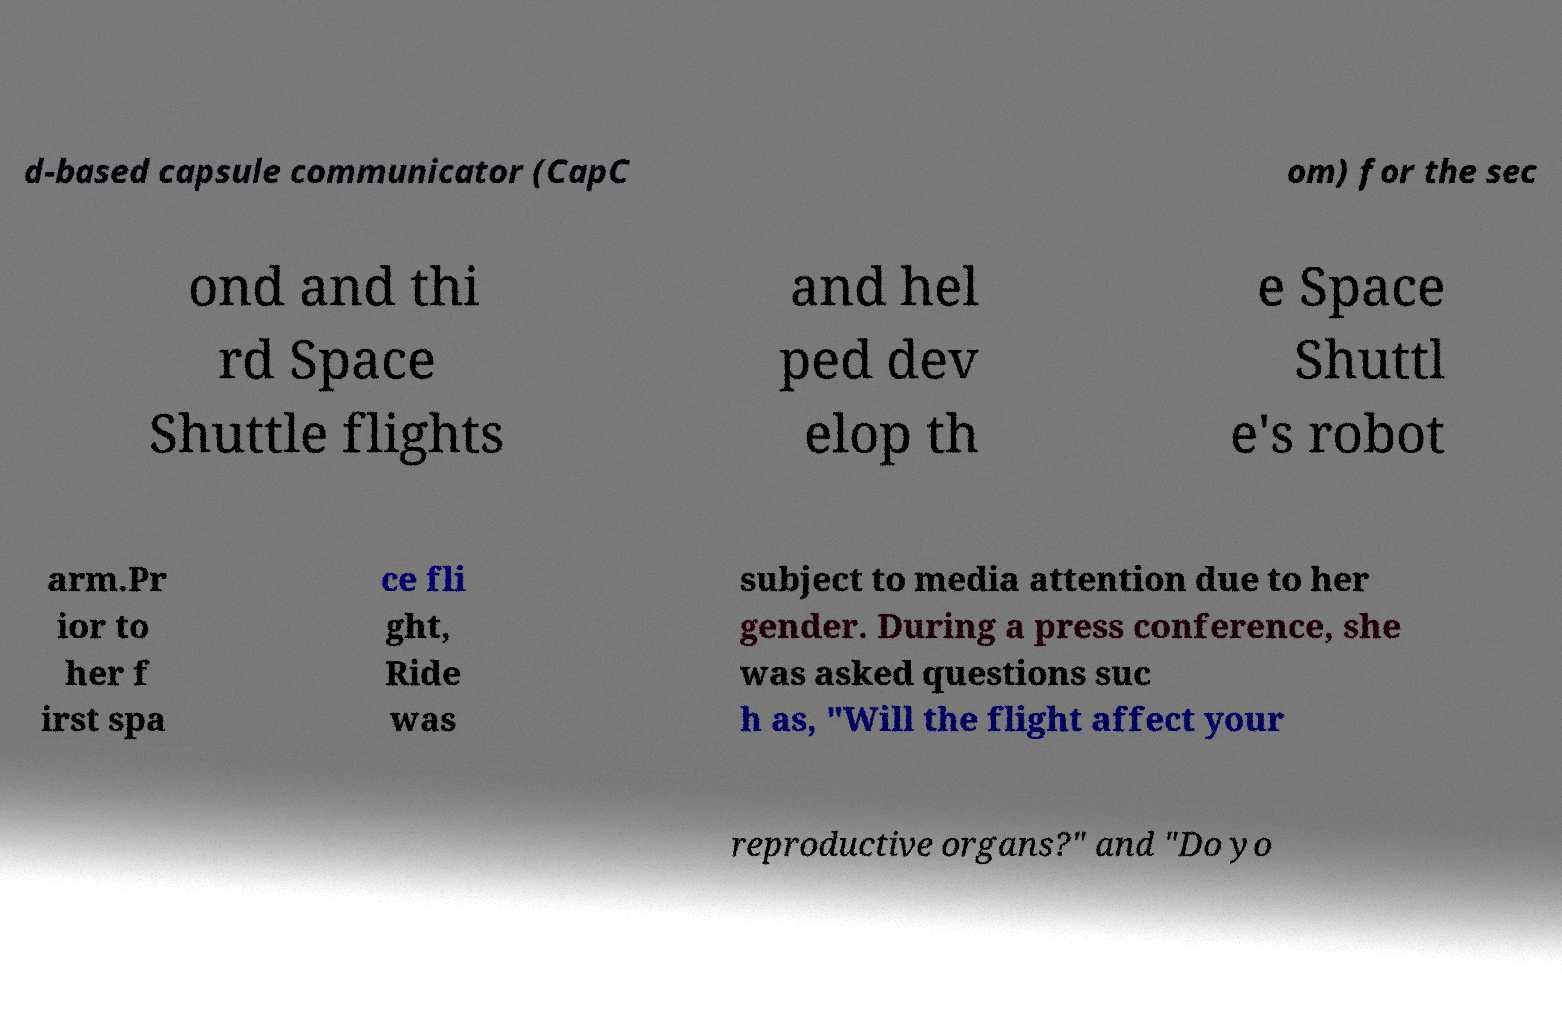What messages or text are displayed in this image? I need them in a readable, typed format. d-based capsule communicator (CapC om) for the sec ond and thi rd Space Shuttle flights and hel ped dev elop th e Space Shuttl e's robot arm.Pr ior to her f irst spa ce fli ght, Ride was subject to media attention due to her gender. During a press conference, she was asked questions suc h as, "Will the flight affect your reproductive organs?" and "Do yo 